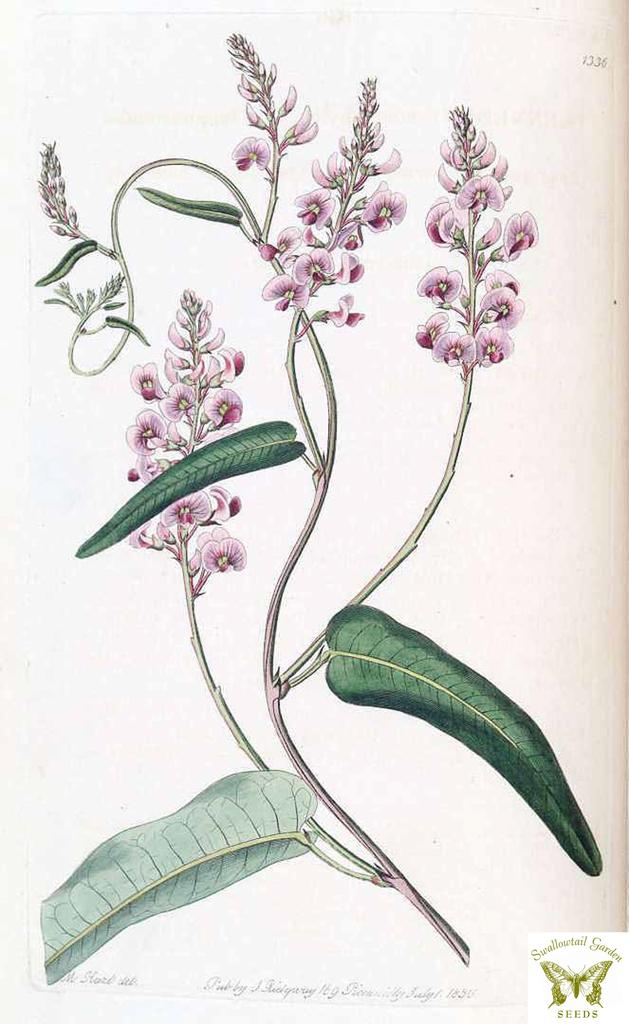What type of image is being described? The image is a printed picture. What is the main subject of the image? There is a plant with flowers and leaves in the image. Is there any text present in the image? Yes, there is text at the bottom of the image. Where is the logo located in the image? The logo is at the bottom right corner of the image. What type of whistle can be heard in the image? There is no whistle present in the image, as it is a printed picture of a plant with flowers and leaves. Is there a baseball game happening in the image? No, there is no baseball game or any reference to baseball in the image. 